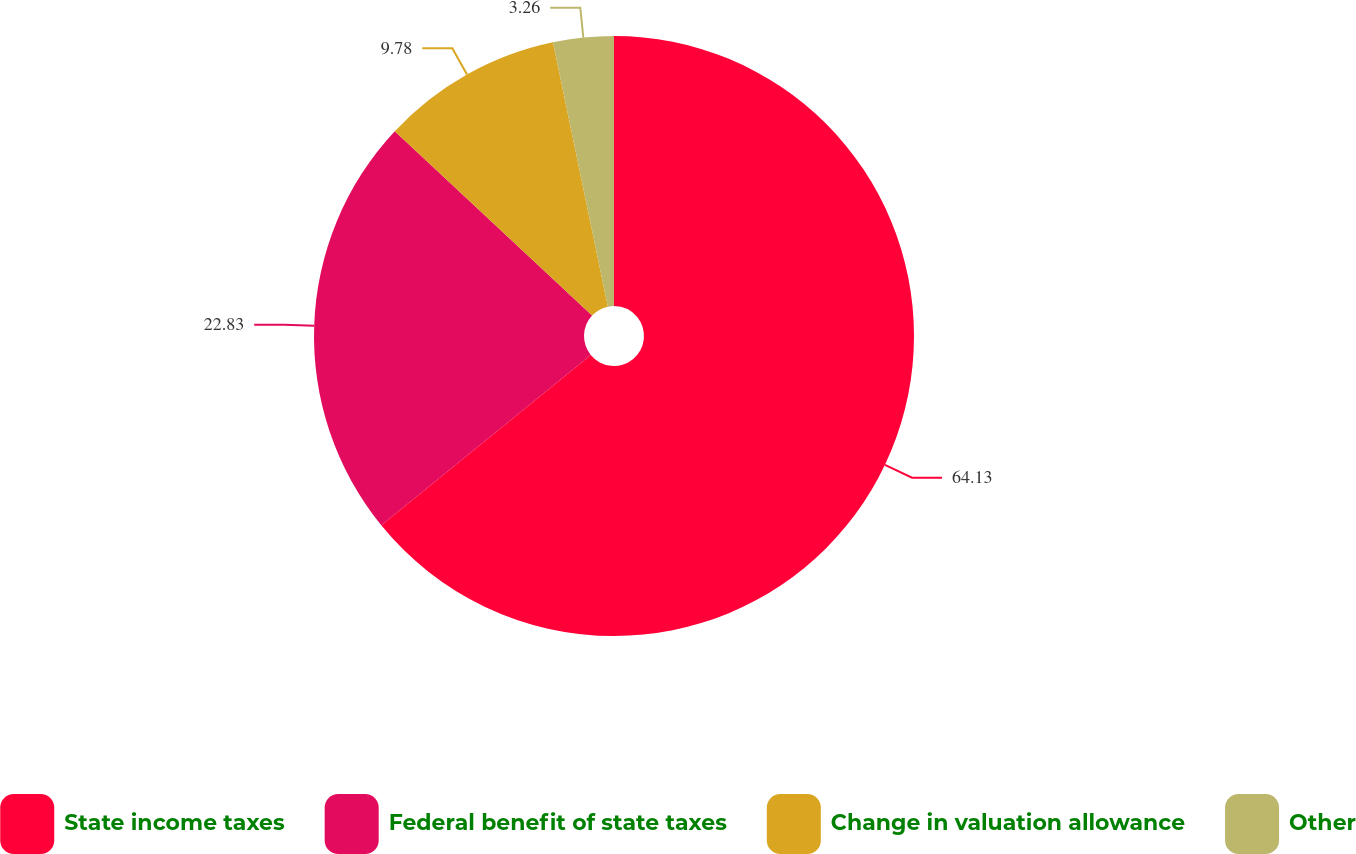Convert chart. <chart><loc_0><loc_0><loc_500><loc_500><pie_chart><fcel>State income taxes<fcel>Federal benefit of state taxes<fcel>Change in valuation allowance<fcel>Other<nl><fcel>64.13%<fcel>22.83%<fcel>9.78%<fcel>3.26%<nl></chart> 